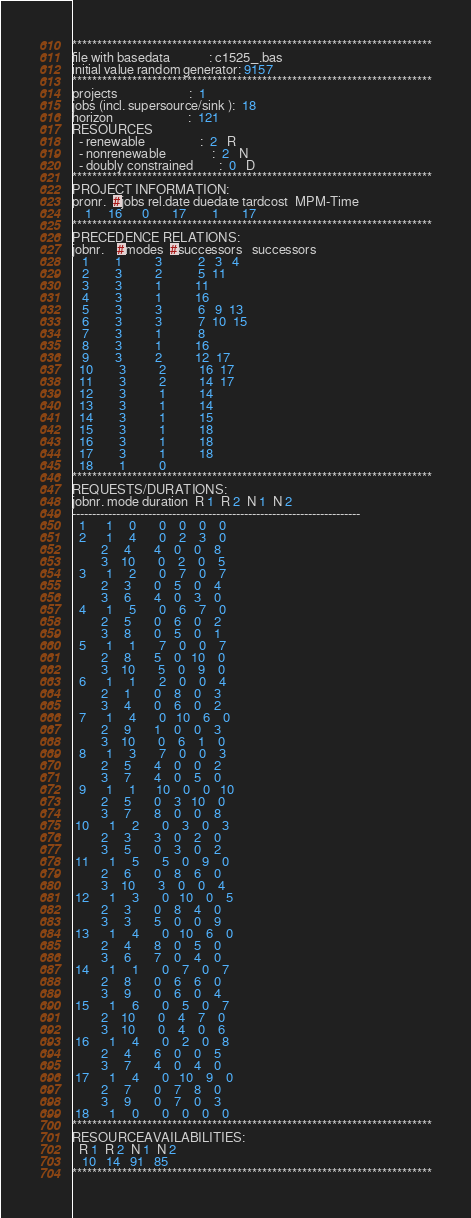<code> <loc_0><loc_0><loc_500><loc_500><_ObjectiveC_>************************************************************************
file with basedata            : c1525_.bas
initial value random generator: 9157
************************************************************************
projects                      :  1
jobs (incl. supersource/sink ):  18
horizon                       :  121
RESOURCES
  - renewable                 :  2   R
  - nonrenewable              :  2   N
  - doubly constrained        :  0   D
************************************************************************
PROJECT INFORMATION:
pronr.  #jobs rel.date duedate tardcost  MPM-Time
    1     16      0       17        1       17
************************************************************************
PRECEDENCE RELATIONS:
jobnr.    #modes  #successors   successors
   1        1          3           2   3   4
   2        3          2           5  11
   3        3          1          11
   4        3          1          16
   5        3          3           6   9  13
   6        3          3           7  10  15
   7        3          1           8
   8        3          1          16
   9        3          2          12  17
  10        3          2          16  17
  11        3          2          14  17
  12        3          1          14
  13        3          1          14
  14        3          1          15
  15        3          1          18
  16        3          1          18
  17        3          1          18
  18        1          0        
************************************************************************
REQUESTS/DURATIONS:
jobnr. mode duration  R 1  R 2  N 1  N 2
------------------------------------------------------------------------
  1      1     0       0    0    0    0
  2      1     4       0    2    3    0
         2     4       4    0    0    8
         3    10       0    2    0    5
  3      1     2       0    7    0    7
         2     3       0    5    0    4
         3     6       4    0    3    0
  4      1     5       0    6    7    0
         2     5       0    6    0    2
         3     8       0    5    0    1
  5      1     1       7    0    0    7
         2     8       5    0   10    0
         3    10       5    0    9    0
  6      1     1       2    0    0    4
         2     1       0    8    0    3
         3     4       0    6    0    2
  7      1     4       0   10    6    0
         2     9       1    0    0    3
         3    10       0    6    1    0
  8      1     3       7    0    0    3
         2     5       4    0    0    2
         3     7       4    0    5    0
  9      1     1      10    0    0   10
         2     5       0    3   10    0
         3     7       8    0    0    8
 10      1     2       0    3    0    3
         2     3       3    0    2    0
         3     5       0    3    0    2
 11      1     5       5    0    9    0
         2     6       0    8    6    0
         3    10       3    0    0    4
 12      1     3       0   10    0    5
         2     3       0    8    4    0
         3     3       5    0    0    9
 13      1     4       0   10    6    0
         2     4       8    0    5    0
         3     6       7    0    4    0
 14      1     1       0    7    0    7
         2     8       0    6    6    0
         3     9       0    6    0    4
 15      1     6       0    5    0    7
         2    10       0    4    7    0
         3    10       0    4    0    6
 16      1     4       0    2    0    8
         2     4       6    0    0    5
         3     7       4    0    4    0
 17      1     4       0   10    9    0
         2     7       0    7    8    0
         3     9       0    7    0    3
 18      1     0       0    0    0    0
************************************************************************
RESOURCEAVAILABILITIES:
  R 1  R 2  N 1  N 2
   10   14   91   85
************************************************************************
</code> 